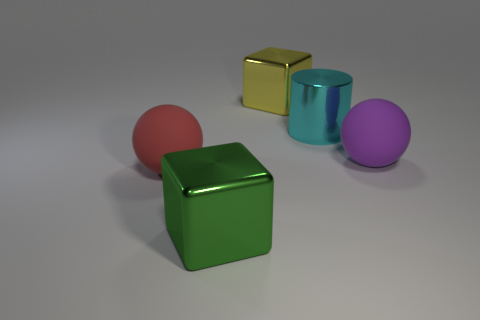What shape is the object that is in front of the purple ball and on the right side of the large red rubber sphere?
Offer a very short reply. Cube. There is a yellow block that is made of the same material as the cyan thing; what size is it?
Make the answer very short. Large. Do the metal cylinder and the matte sphere that is on the left side of the large green thing have the same color?
Keep it short and to the point. No. What material is the large object that is on the left side of the yellow metal object and behind the green block?
Your answer should be compact. Rubber. There is a big metallic thing to the left of the yellow shiny object; does it have the same shape as the object left of the green metallic thing?
Your answer should be compact. No. Is there a green cylinder?
Make the answer very short. No. There is another object that is the same shape as the large purple thing; what is its color?
Provide a succinct answer. Red. There is a matte ball that is the same size as the purple thing; what color is it?
Keep it short and to the point. Red. Does the large cyan object have the same material as the red object?
Give a very brief answer. No. How many large matte balls have the same color as the large metallic cylinder?
Make the answer very short. 0. 